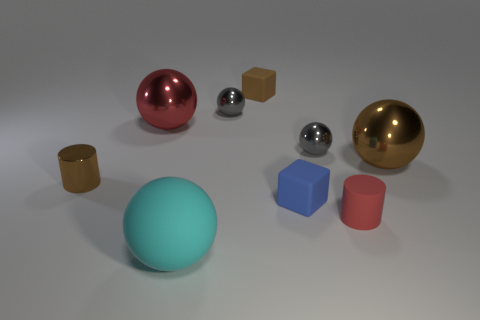Subtract all cyan spheres. How many spheres are left? 4 Subtract all brown balls. How many balls are left? 4 Subtract all brown spheres. Subtract all green blocks. How many spheres are left? 4 Subtract all cubes. How many objects are left? 7 Add 6 small blue things. How many small blue things are left? 7 Add 9 green rubber cylinders. How many green rubber cylinders exist? 9 Subtract 0 yellow spheres. How many objects are left? 9 Subtract all tiny gray balls. Subtract all tiny things. How many objects are left? 1 